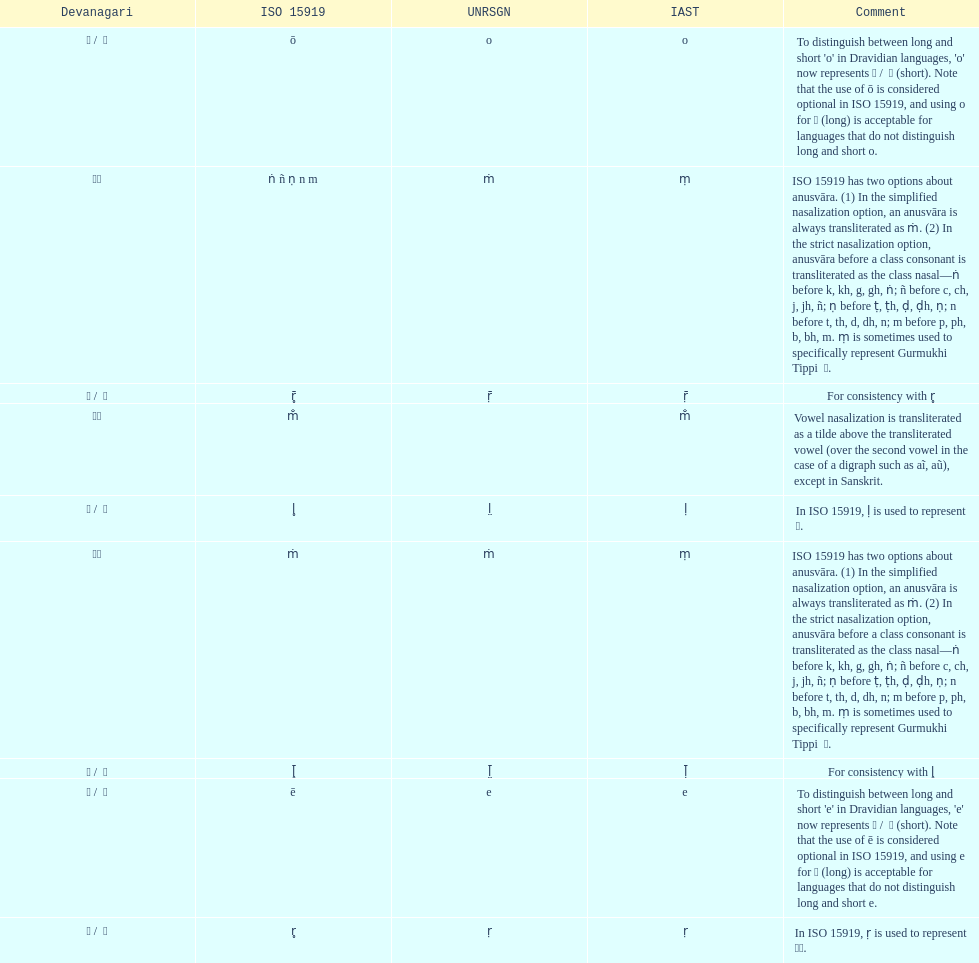Which devanagari transliteration is listed on the top of the table? ए / े. 